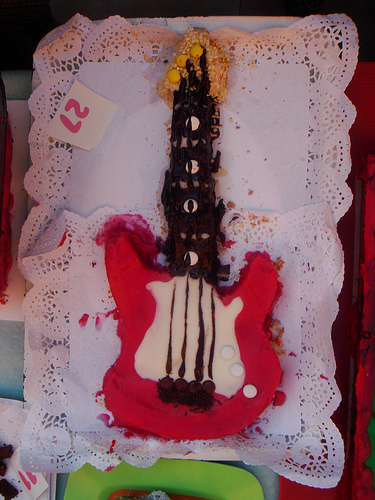<image>
Is there a number on the guitar? No. The number is not positioned on the guitar. They may be near each other, but the number is not supported by or resting on top of the guitar. 